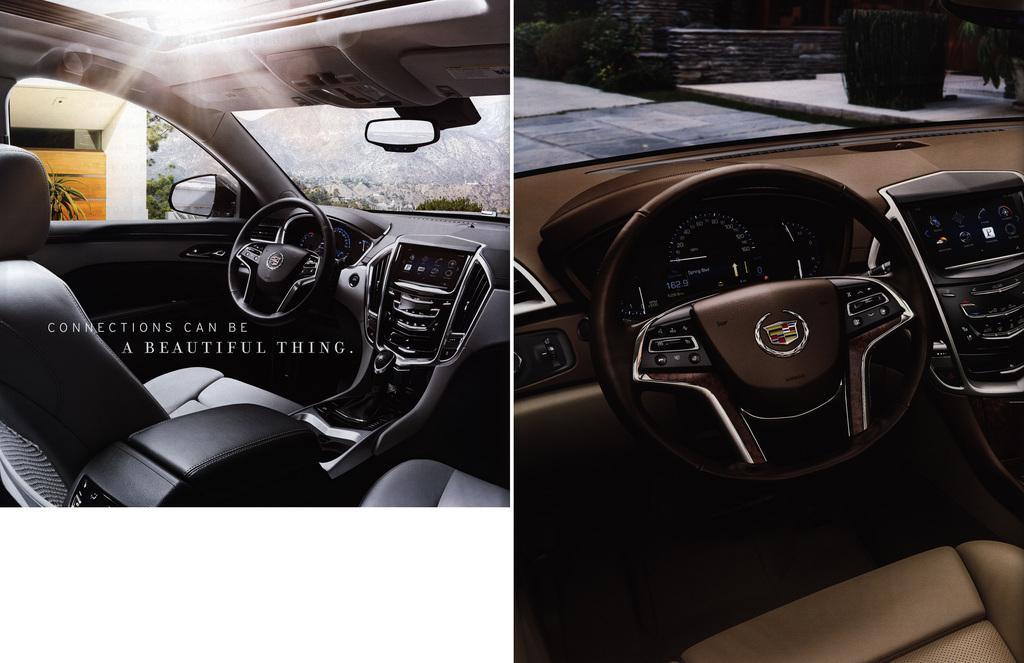Please provide a concise description of this image. This is a collage image and here we can see inside view of vehicles and there is some text and we can see steering and some buttons and there are mirrors and through the glass we can see a building and some trees. 